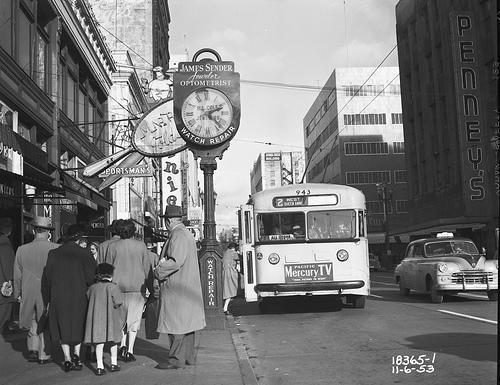How many people are visible?
Give a very brief answer. 5. How many cars are there?
Give a very brief answer. 1. How many people are wearing skis in this image?
Give a very brief answer. 0. 